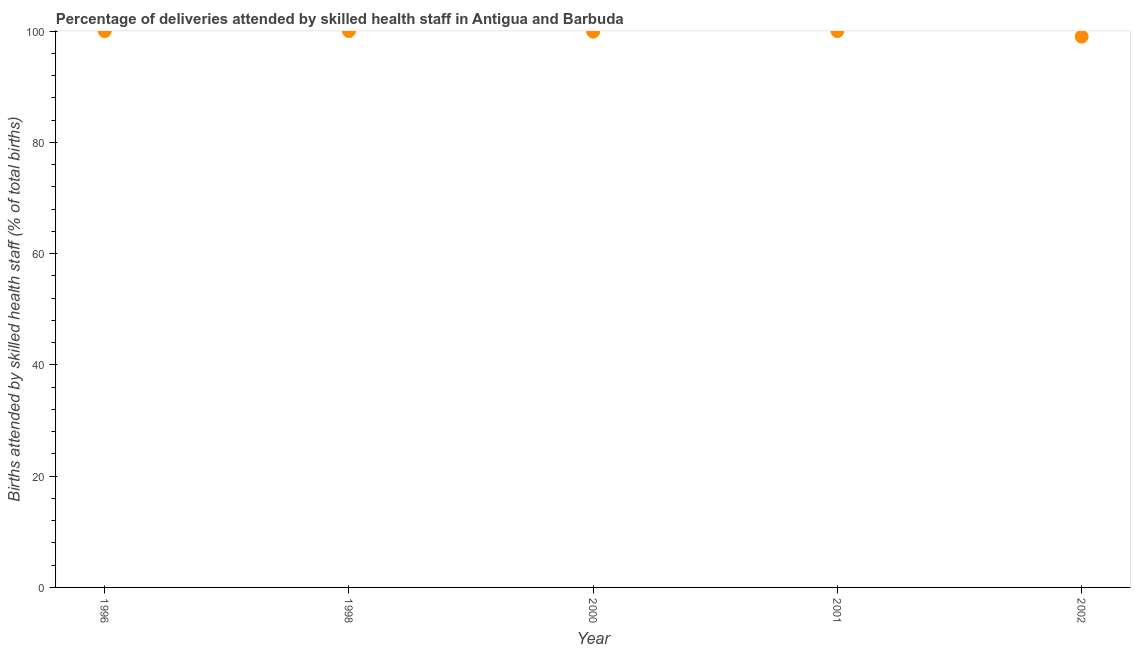What is the number of births attended by skilled health staff in 1996?
Offer a very short reply. 100. Across all years, what is the maximum number of births attended by skilled health staff?
Offer a very short reply. 100. Across all years, what is the minimum number of births attended by skilled health staff?
Your answer should be compact. 99. In which year was the number of births attended by skilled health staff maximum?
Make the answer very short. 1996. What is the sum of the number of births attended by skilled health staff?
Offer a very short reply. 498.9. What is the difference between the number of births attended by skilled health staff in 1998 and 2000?
Make the answer very short. 0.1. What is the average number of births attended by skilled health staff per year?
Give a very brief answer. 99.78. What is the median number of births attended by skilled health staff?
Give a very brief answer. 100. What is the ratio of the number of births attended by skilled health staff in 1998 to that in 2002?
Your response must be concise. 1.01. Is the number of births attended by skilled health staff in 2000 less than that in 2001?
Keep it short and to the point. Yes. Is the sum of the number of births attended by skilled health staff in 2000 and 2002 greater than the maximum number of births attended by skilled health staff across all years?
Provide a succinct answer. Yes. In how many years, is the number of births attended by skilled health staff greater than the average number of births attended by skilled health staff taken over all years?
Make the answer very short. 4. Does the number of births attended by skilled health staff monotonically increase over the years?
Provide a succinct answer. No. How many years are there in the graph?
Offer a very short reply. 5. Are the values on the major ticks of Y-axis written in scientific E-notation?
Ensure brevity in your answer.  No. Does the graph contain any zero values?
Your answer should be compact. No. What is the title of the graph?
Keep it short and to the point. Percentage of deliveries attended by skilled health staff in Antigua and Barbuda. What is the label or title of the Y-axis?
Your answer should be very brief. Births attended by skilled health staff (% of total births). What is the Births attended by skilled health staff (% of total births) in 2000?
Your answer should be compact. 99.9. What is the Births attended by skilled health staff (% of total births) in 2001?
Your response must be concise. 100. What is the difference between the Births attended by skilled health staff (% of total births) in 1996 and 2001?
Offer a terse response. 0. What is the difference between the Births attended by skilled health staff (% of total births) in 1996 and 2002?
Provide a short and direct response. 1. What is the ratio of the Births attended by skilled health staff (% of total births) in 1996 to that in 1998?
Give a very brief answer. 1. What is the ratio of the Births attended by skilled health staff (% of total births) in 1996 to that in 2001?
Keep it short and to the point. 1. What is the ratio of the Births attended by skilled health staff (% of total births) in 1998 to that in 2000?
Offer a very short reply. 1. What is the ratio of the Births attended by skilled health staff (% of total births) in 1998 to that in 2001?
Ensure brevity in your answer.  1. What is the ratio of the Births attended by skilled health staff (% of total births) in 1998 to that in 2002?
Offer a very short reply. 1.01. What is the ratio of the Births attended by skilled health staff (% of total births) in 2000 to that in 2002?
Ensure brevity in your answer.  1.01. What is the ratio of the Births attended by skilled health staff (% of total births) in 2001 to that in 2002?
Provide a short and direct response. 1.01. 